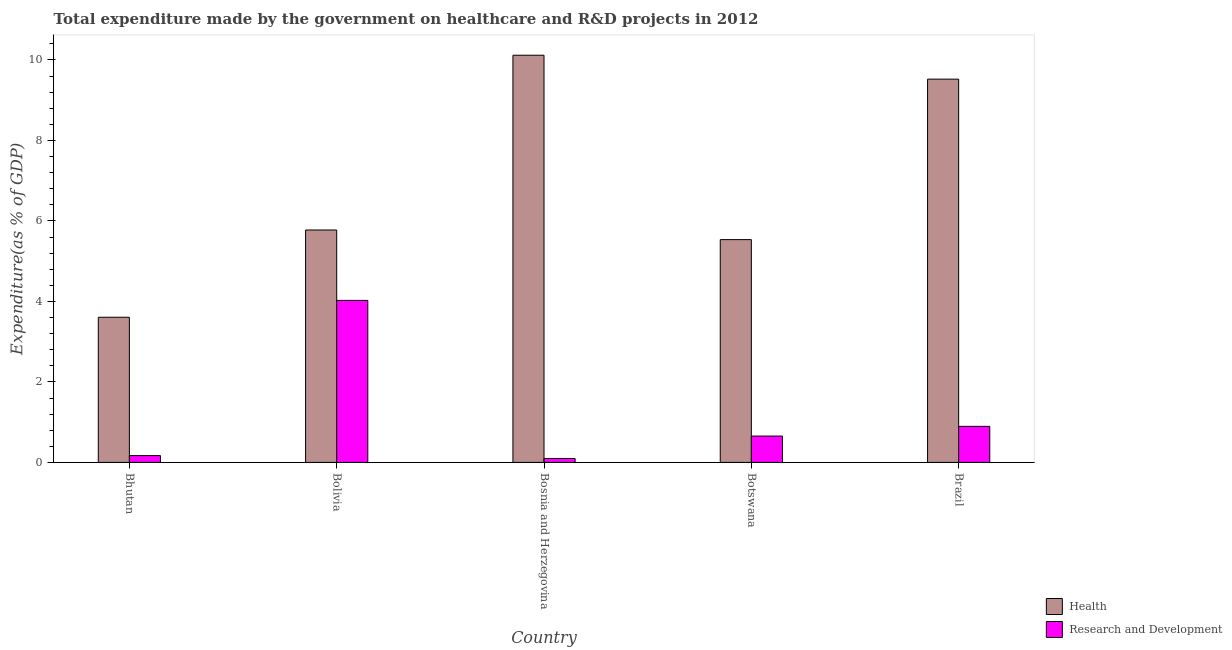How many groups of bars are there?
Your answer should be compact. 5. Are the number of bars per tick equal to the number of legend labels?
Offer a terse response. Yes. Are the number of bars on each tick of the X-axis equal?
Keep it short and to the point. Yes. What is the expenditure in r&d in Brazil?
Your answer should be very brief. 0.9. Across all countries, what is the maximum expenditure in healthcare?
Your response must be concise. 10.12. Across all countries, what is the minimum expenditure in healthcare?
Your answer should be very brief. 3.61. In which country was the expenditure in healthcare minimum?
Offer a terse response. Bhutan. What is the total expenditure in r&d in the graph?
Your answer should be compact. 5.84. What is the difference between the expenditure in healthcare in Bhutan and that in Brazil?
Offer a very short reply. -5.92. What is the difference between the expenditure in healthcare in Brazil and the expenditure in r&d in Botswana?
Provide a succinct answer. 8.87. What is the average expenditure in r&d per country?
Keep it short and to the point. 1.17. What is the difference between the expenditure in healthcare and expenditure in r&d in Bolivia?
Your answer should be very brief. 1.75. What is the ratio of the expenditure in healthcare in Bosnia and Herzegovina to that in Botswana?
Provide a short and direct response. 1.83. Is the expenditure in r&d in Bhutan less than that in Botswana?
Your response must be concise. Yes. What is the difference between the highest and the second highest expenditure in healthcare?
Keep it short and to the point. 0.59. What is the difference between the highest and the lowest expenditure in healthcare?
Make the answer very short. 6.51. Is the sum of the expenditure in r&d in Bosnia and Herzegovina and Botswana greater than the maximum expenditure in healthcare across all countries?
Offer a terse response. No. What does the 1st bar from the left in Botswana represents?
Your response must be concise. Health. What does the 2nd bar from the right in Brazil represents?
Provide a short and direct response. Health. How many bars are there?
Ensure brevity in your answer.  10. Are all the bars in the graph horizontal?
Offer a very short reply. No. How many countries are there in the graph?
Ensure brevity in your answer.  5. What is the difference between two consecutive major ticks on the Y-axis?
Offer a very short reply. 2. Are the values on the major ticks of Y-axis written in scientific E-notation?
Ensure brevity in your answer.  No. Does the graph contain any zero values?
Provide a succinct answer. No. Does the graph contain grids?
Keep it short and to the point. No. How many legend labels are there?
Offer a terse response. 2. What is the title of the graph?
Make the answer very short. Total expenditure made by the government on healthcare and R&D projects in 2012. Does "Register a business" appear as one of the legend labels in the graph?
Keep it short and to the point. No. What is the label or title of the Y-axis?
Your answer should be compact. Expenditure(as % of GDP). What is the Expenditure(as % of GDP) of Health in Bhutan?
Offer a terse response. 3.61. What is the Expenditure(as % of GDP) of Research and Development in Bhutan?
Make the answer very short. 0.17. What is the Expenditure(as % of GDP) of Health in Bolivia?
Ensure brevity in your answer.  5.77. What is the Expenditure(as % of GDP) in Research and Development in Bolivia?
Provide a succinct answer. 4.03. What is the Expenditure(as % of GDP) of Health in Bosnia and Herzegovina?
Ensure brevity in your answer.  10.12. What is the Expenditure(as % of GDP) of Research and Development in Bosnia and Herzegovina?
Ensure brevity in your answer.  0.1. What is the Expenditure(as % of GDP) of Health in Botswana?
Provide a succinct answer. 5.54. What is the Expenditure(as % of GDP) in Research and Development in Botswana?
Provide a succinct answer. 0.65. What is the Expenditure(as % of GDP) in Health in Brazil?
Your response must be concise. 9.52. What is the Expenditure(as % of GDP) of Research and Development in Brazil?
Provide a short and direct response. 0.9. Across all countries, what is the maximum Expenditure(as % of GDP) in Health?
Offer a very short reply. 10.12. Across all countries, what is the maximum Expenditure(as % of GDP) in Research and Development?
Offer a terse response. 4.03. Across all countries, what is the minimum Expenditure(as % of GDP) of Health?
Ensure brevity in your answer.  3.61. Across all countries, what is the minimum Expenditure(as % of GDP) in Research and Development?
Your answer should be compact. 0.1. What is the total Expenditure(as % of GDP) of Health in the graph?
Provide a succinct answer. 34.56. What is the total Expenditure(as % of GDP) in Research and Development in the graph?
Make the answer very short. 5.84. What is the difference between the Expenditure(as % of GDP) of Health in Bhutan and that in Bolivia?
Offer a very short reply. -2.17. What is the difference between the Expenditure(as % of GDP) in Research and Development in Bhutan and that in Bolivia?
Provide a succinct answer. -3.86. What is the difference between the Expenditure(as % of GDP) of Health in Bhutan and that in Bosnia and Herzegovina?
Your answer should be very brief. -6.51. What is the difference between the Expenditure(as % of GDP) in Research and Development in Bhutan and that in Bosnia and Herzegovina?
Provide a succinct answer. 0.07. What is the difference between the Expenditure(as % of GDP) of Health in Bhutan and that in Botswana?
Give a very brief answer. -1.93. What is the difference between the Expenditure(as % of GDP) of Research and Development in Bhutan and that in Botswana?
Your answer should be compact. -0.49. What is the difference between the Expenditure(as % of GDP) of Health in Bhutan and that in Brazil?
Your response must be concise. -5.92. What is the difference between the Expenditure(as % of GDP) of Research and Development in Bhutan and that in Brazil?
Your answer should be very brief. -0.73. What is the difference between the Expenditure(as % of GDP) in Health in Bolivia and that in Bosnia and Herzegovina?
Keep it short and to the point. -4.34. What is the difference between the Expenditure(as % of GDP) of Research and Development in Bolivia and that in Bosnia and Herzegovina?
Give a very brief answer. 3.93. What is the difference between the Expenditure(as % of GDP) of Health in Bolivia and that in Botswana?
Provide a succinct answer. 0.24. What is the difference between the Expenditure(as % of GDP) in Research and Development in Bolivia and that in Botswana?
Keep it short and to the point. 3.37. What is the difference between the Expenditure(as % of GDP) in Health in Bolivia and that in Brazil?
Ensure brevity in your answer.  -3.75. What is the difference between the Expenditure(as % of GDP) of Research and Development in Bolivia and that in Brazil?
Give a very brief answer. 3.13. What is the difference between the Expenditure(as % of GDP) of Health in Bosnia and Herzegovina and that in Botswana?
Offer a very short reply. 4.58. What is the difference between the Expenditure(as % of GDP) in Research and Development in Bosnia and Herzegovina and that in Botswana?
Provide a succinct answer. -0.56. What is the difference between the Expenditure(as % of GDP) of Health in Bosnia and Herzegovina and that in Brazil?
Your answer should be very brief. 0.59. What is the difference between the Expenditure(as % of GDP) of Research and Development in Bosnia and Herzegovina and that in Brazil?
Make the answer very short. -0.8. What is the difference between the Expenditure(as % of GDP) in Health in Botswana and that in Brazil?
Offer a terse response. -3.99. What is the difference between the Expenditure(as % of GDP) of Research and Development in Botswana and that in Brazil?
Provide a short and direct response. -0.24. What is the difference between the Expenditure(as % of GDP) of Health in Bhutan and the Expenditure(as % of GDP) of Research and Development in Bolivia?
Provide a succinct answer. -0.42. What is the difference between the Expenditure(as % of GDP) of Health in Bhutan and the Expenditure(as % of GDP) of Research and Development in Bosnia and Herzegovina?
Offer a terse response. 3.51. What is the difference between the Expenditure(as % of GDP) in Health in Bhutan and the Expenditure(as % of GDP) in Research and Development in Botswana?
Provide a succinct answer. 2.95. What is the difference between the Expenditure(as % of GDP) in Health in Bhutan and the Expenditure(as % of GDP) in Research and Development in Brazil?
Give a very brief answer. 2.71. What is the difference between the Expenditure(as % of GDP) in Health in Bolivia and the Expenditure(as % of GDP) in Research and Development in Bosnia and Herzegovina?
Provide a short and direct response. 5.68. What is the difference between the Expenditure(as % of GDP) of Health in Bolivia and the Expenditure(as % of GDP) of Research and Development in Botswana?
Your answer should be very brief. 5.12. What is the difference between the Expenditure(as % of GDP) in Health in Bolivia and the Expenditure(as % of GDP) in Research and Development in Brazil?
Your response must be concise. 4.88. What is the difference between the Expenditure(as % of GDP) of Health in Bosnia and Herzegovina and the Expenditure(as % of GDP) of Research and Development in Botswana?
Make the answer very short. 9.46. What is the difference between the Expenditure(as % of GDP) of Health in Bosnia and Herzegovina and the Expenditure(as % of GDP) of Research and Development in Brazil?
Give a very brief answer. 9.22. What is the difference between the Expenditure(as % of GDP) of Health in Botswana and the Expenditure(as % of GDP) of Research and Development in Brazil?
Make the answer very short. 4.64. What is the average Expenditure(as % of GDP) in Health per country?
Provide a succinct answer. 6.91. What is the average Expenditure(as % of GDP) of Research and Development per country?
Offer a very short reply. 1.17. What is the difference between the Expenditure(as % of GDP) in Health and Expenditure(as % of GDP) in Research and Development in Bhutan?
Provide a succinct answer. 3.44. What is the difference between the Expenditure(as % of GDP) of Health and Expenditure(as % of GDP) of Research and Development in Bolivia?
Offer a very short reply. 1.75. What is the difference between the Expenditure(as % of GDP) of Health and Expenditure(as % of GDP) of Research and Development in Bosnia and Herzegovina?
Provide a short and direct response. 10.02. What is the difference between the Expenditure(as % of GDP) of Health and Expenditure(as % of GDP) of Research and Development in Botswana?
Your answer should be compact. 4.88. What is the difference between the Expenditure(as % of GDP) in Health and Expenditure(as % of GDP) in Research and Development in Brazil?
Offer a terse response. 8.63. What is the ratio of the Expenditure(as % of GDP) in Health in Bhutan to that in Bolivia?
Offer a terse response. 0.62. What is the ratio of the Expenditure(as % of GDP) of Research and Development in Bhutan to that in Bolivia?
Give a very brief answer. 0.04. What is the ratio of the Expenditure(as % of GDP) of Health in Bhutan to that in Bosnia and Herzegovina?
Provide a short and direct response. 0.36. What is the ratio of the Expenditure(as % of GDP) in Research and Development in Bhutan to that in Bosnia and Herzegovina?
Your answer should be compact. 1.74. What is the ratio of the Expenditure(as % of GDP) of Health in Bhutan to that in Botswana?
Your answer should be very brief. 0.65. What is the ratio of the Expenditure(as % of GDP) of Research and Development in Bhutan to that in Botswana?
Your answer should be compact. 0.26. What is the ratio of the Expenditure(as % of GDP) in Health in Bhutan to that in Brazil?
Make the answer very short. 0.38. What is the ratio of the Expenditure(as % of GDP) of Research and Development in Bhutan to that in Brazil?
Give a very brief answer. 0.19. What is the ratio of the Expenditure(as % of GDP) of Health in Bolivia to that in Bosnia and Herzegovina?
Your answer should be compact. 0.57. What is the ratio of the Expenditure(as % of GDP) in Research and Development in Bolivia to that in Bosnia and Herzegovina?
Provide a short and direct response. 41.41. What is the ratio of the Expenditure(as % of GDP) in Health in Bolivia to that in Botswana?
Your response must be concise. 1.04. What is the ratio of the Expenditure(as % of GDP) in Research and Development in Bolivia to that in Botswana?
Ensure brevity in your answer.  6.15. What is the ratio of the Expenditure(as % of GDP) in Health in Bolivia to that in Brazil?
Provide a succinct answer. 0.61. What is the ratio of the Expenditure(as % of GDP) of Research and Development in Bolivia to that in Brazil?
Give a very brief answer. 4.49. What is the ratio of the Expenditure(as % of GDP) in Health in Bosnia and Herzegovina to that in Botswana?
Your answer should be very brief. 1.83. What is the ratio of the Expenditure(as % of GDP) of Research and Development in Bosnia and Herzegovina to that in Botswana?
Offer a terse response. 0.15. What is the ratio of the Expenditure(as % of GDP) in Health in Bosnia and Herzegovina to that in Brazil?
Provide a short and direct response. 1.06. What is the ratio of the Expenditure(as % of GDP) of Research and Development in Bosnia and Herzegovina to that in Brazil?
Give a very brief answer. 0.11. What is the ratio of the Expenditure(as % of GDP) of Health in Botswana to that in Brazil?
Give a very brief answer. 0.58. What is the ratio of the Expenditure(as % of GDP) of Research and Development in Botswana to that in Brazil?
Your answer should be compact. 0.73. What is the difference between the highest and the second highest Expenditure(as % of GDP) in Health?
Make the answer very short. 0.59. What is the difference between the highest and the second highest Expenditure(as % of GDP) in Research and Development?
Provide a succinct answer. 3.13. What is the difference between the highest and the lowest Expenditure(as % of GDP) in Health?
Ensure brevity in your answer.  6.51. What is the difference between the highest and the lowest Expenditure(as % of GDP) in Research and Development?
Offer a very short reply. 3.93. 